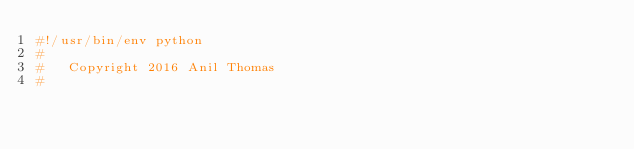Convert code to text. <code><loc_0><loc_0><loc_500><loc_500><_Python_>#!/usr/bin/env python
#
#   Copyright 2016 Anil Thomas
#</code> 